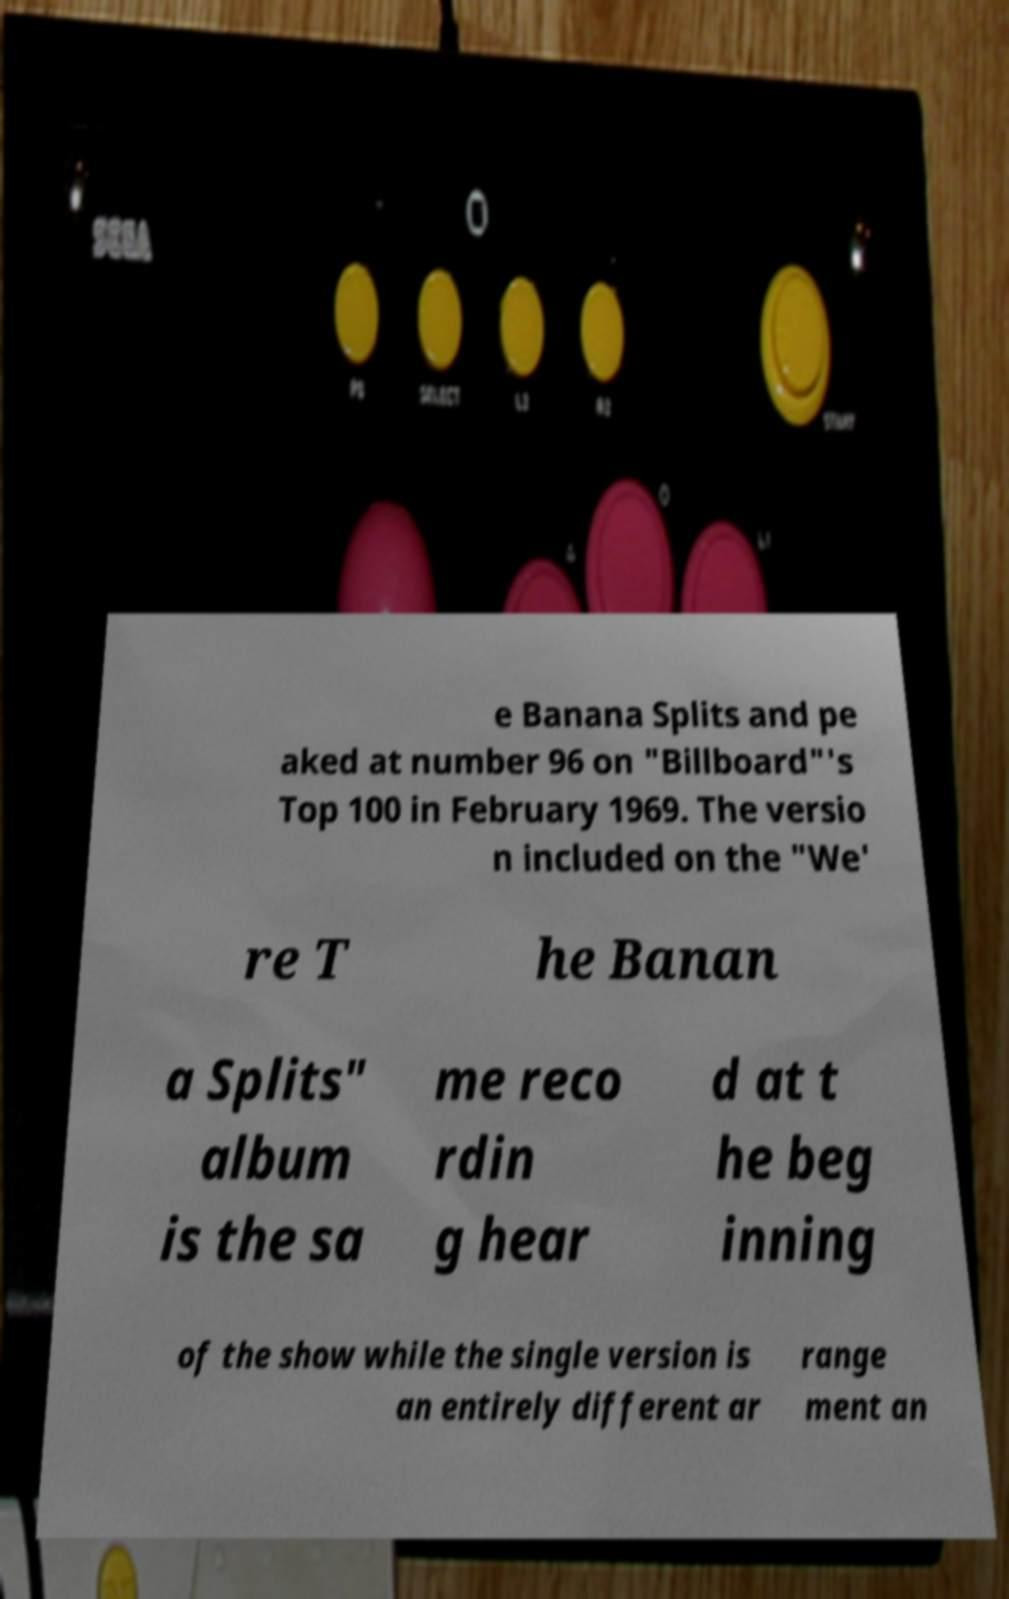I need the written content from this picture converted into text. Can you do that? e Banana Splits and pe aked at number 96 on "Billboard"'s Top 100 in February 1969. The versio n included on the "We' re T he Banan a Splits" album is the sa me reco rdin g hear d at t he beg inning of the show while the single version is an entirely different ar range ment an 